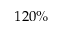<formula> <loc_0><loc_0><loc_500><loc_500>1 2 0 \%</formula> 